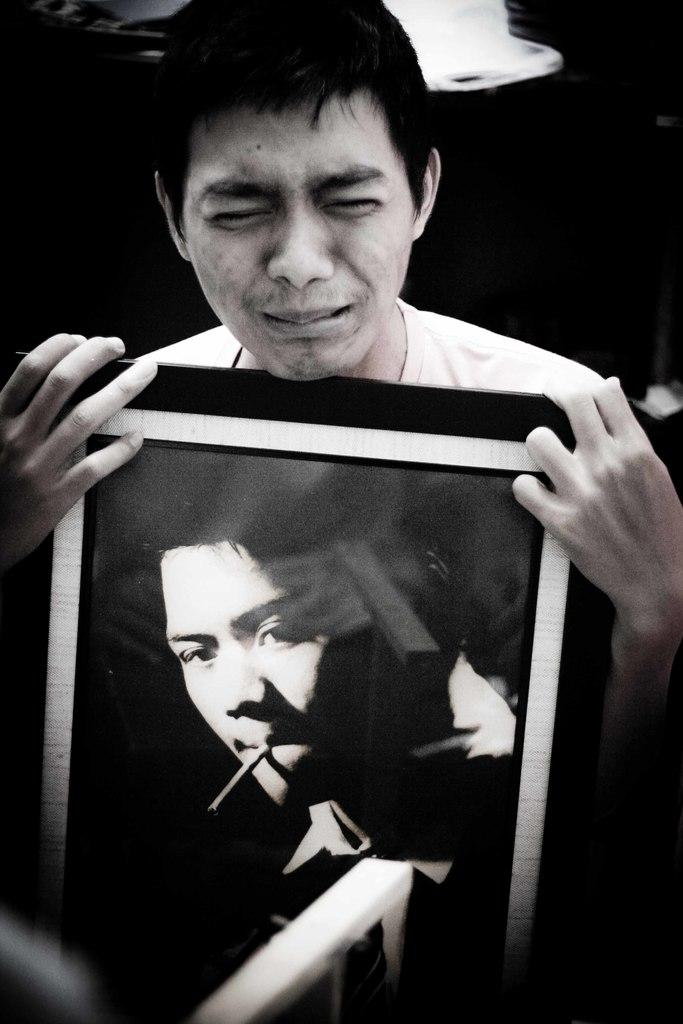Who is the main subject in the image? There is a man in the image. What is the man holding in his hand? The man is holding a picture frame in his hand. What can be seen on the picture frame? There is a picture of a person on the frame. Can you describe the background of the image? The background of the image is dark. What type of rail can be seen in the image? There is no rail present in the image. Is the man's brother also in the image? The provided facts do not mention the man's brother, so we cannot determine if he is in the image or not. 